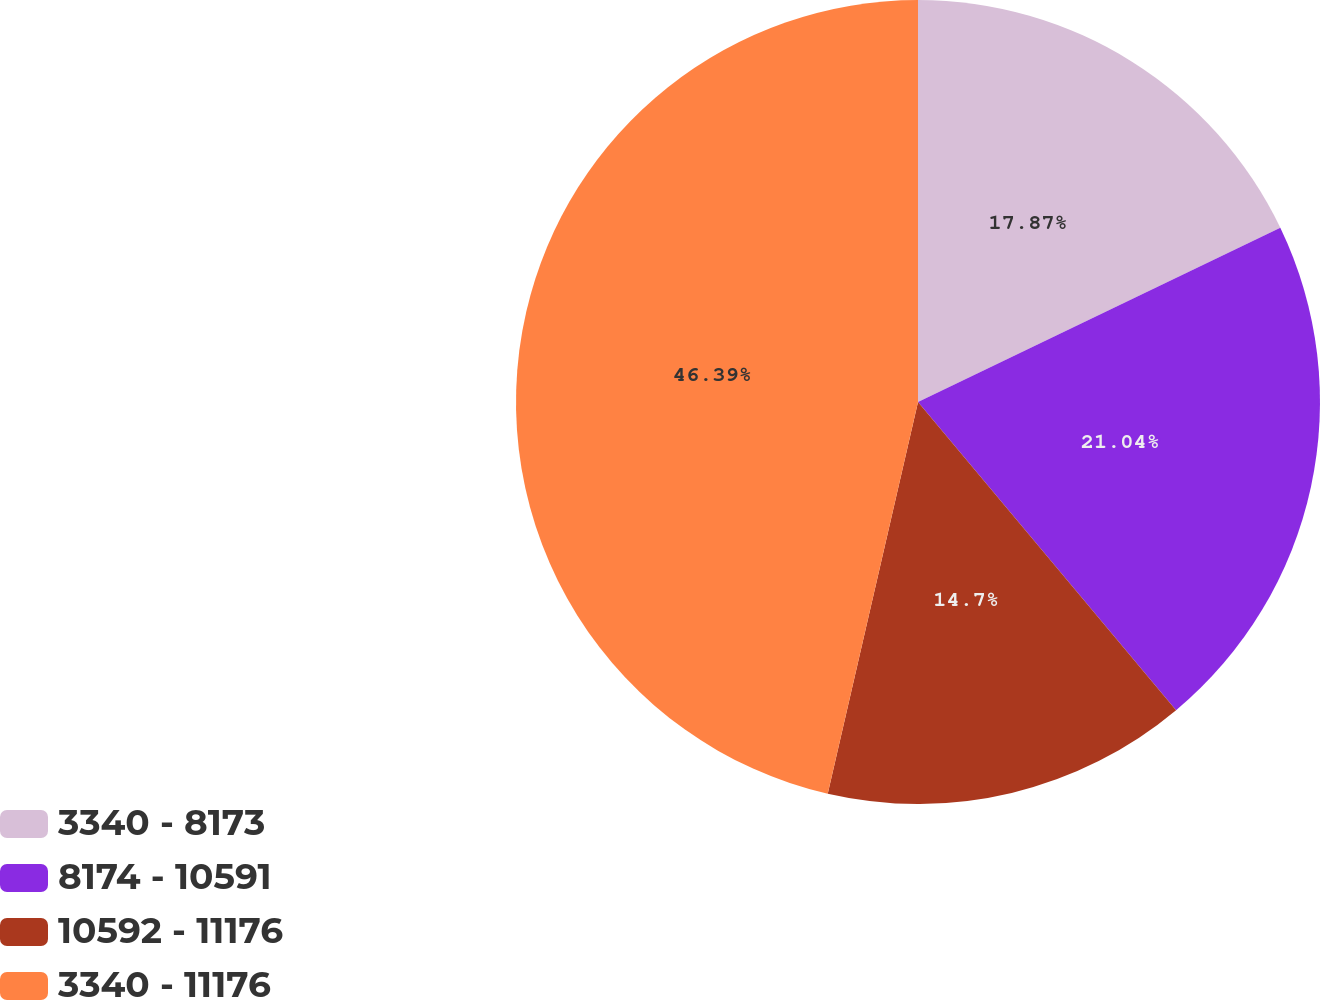Convert chart to OTSL. <chart><loc_0><loc_0><loc_500><loc_500><pie_chart><fcel>3340 - 8173<fcel>8174 - 10591<fcel>10592 - 11176<fcel>3340 - 11176<nl><fcel>17.87%<fcel>21.04%<fcel>14.7%<fcel>46.4%<nl></chart> 